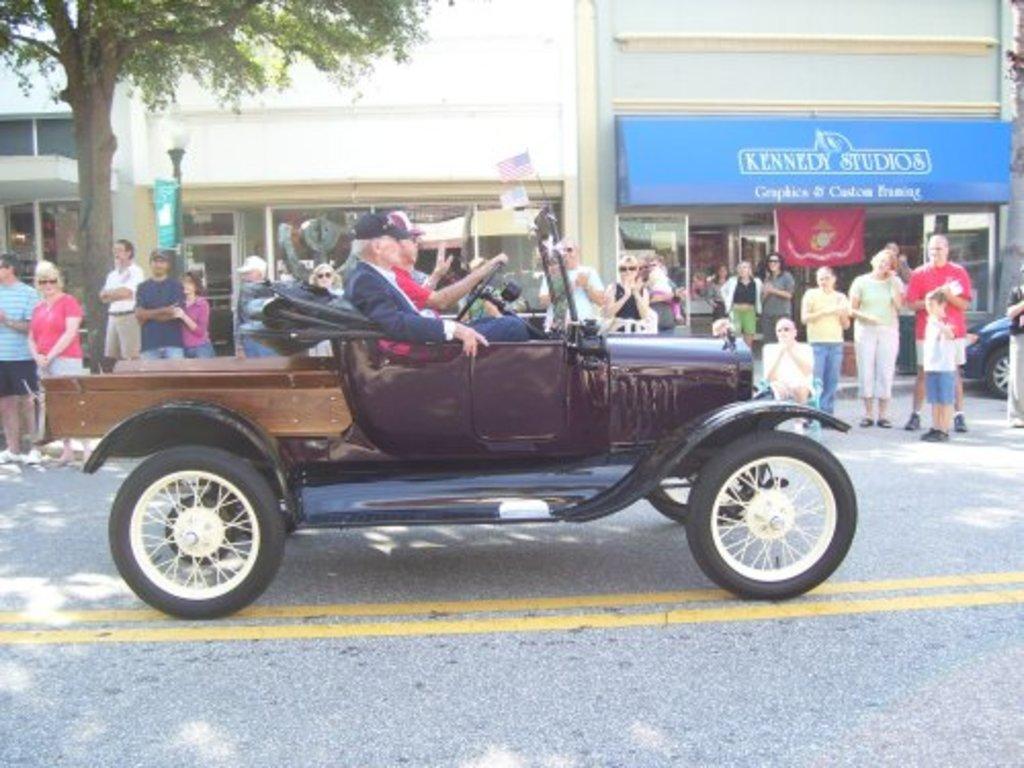How would you summarize this image in a sentence or two? There is a group of people. They are standing on a road. In the center two persons are sitting on a jeep seat. They are riding a jeep. We can see in background buildings and trees. 